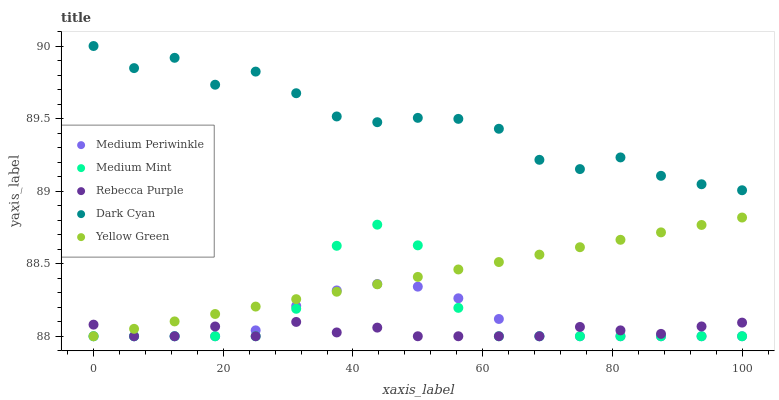Does Rebecca Purple have the minimum area under the curve?
Answer yes or no. Yes. Does Dark Cyan have the maximum area under the curve?
Answer yes or no. Yes. Does Medium Periwinkle have the minimum area under the curve?
Answer yes or no. No. Does Medium Periwinkle have the maximum area under the curve?
Answer yes or no. No. Is Yellow Green the smoothest?
Answer yes or no. Yes. Is Dark Cyan the roughest?
Answer yes or no. Yes. Is Medium Periwinkle the smoothest?
Answer yes or no. No. Is Medium Periwinkle the roughest?
Answer yes or no. No. Does Medium Mint have the lowest value?
Answer yes or no. Yes. Does Dark Cyan have the lowest value?
Answer yes or no. No. Does Dark Cyan have the highest value?
Answer yes or no. Yes. Does Medium Periwinkle have the highest value?
Answer yes or no. No. Is Yellow Green less than Dark Cyan?
Answer yes or no. Yes. Is Dark Cyan greater than Yellow Green?
Answer yes or no. Yes. Does Medium Mint intersect Medium Periwinkle?
Answer yes or no. Yes. Is Medium Mint less than Medium Periwinkle?
Answer yes or no. No. Is Medium Mint greater than Medium Periwinkle?
Answer yes or no. No. Does Yellow Green intersect Dark Cyan?
Answer yes or no. No. 